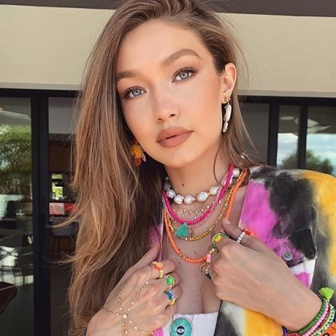Describe the setting and environment surrounding the woman in detail. The setting surrounding the woman features an urban backdrop. Behind her, we see a building with a modern facade, accentuated by large windows that reflect some of the outdoor scenery. A tree with lush green leaves is visible to the side, indicating the presence of nature amidst the urban space. The overall atmosphere suggests a blend of city life with pockets of greenery, creating a balanced and aesthetically pleasing environment. 